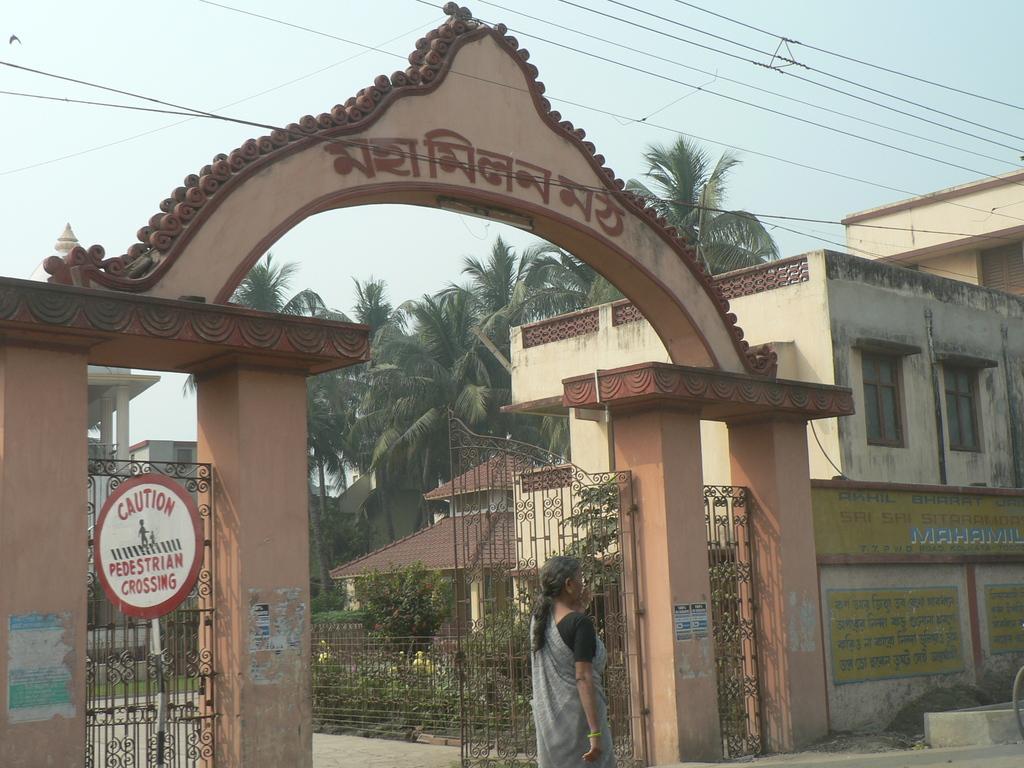Describe this image in one or two sentences. In the picture we can see a wall with an entrance gate and near the gate we can see a woman standing and in the background, we can see a house building with windows, to the path railings, plants, trees, wires and sky and we can also see a caution board to the pole near the gate. 